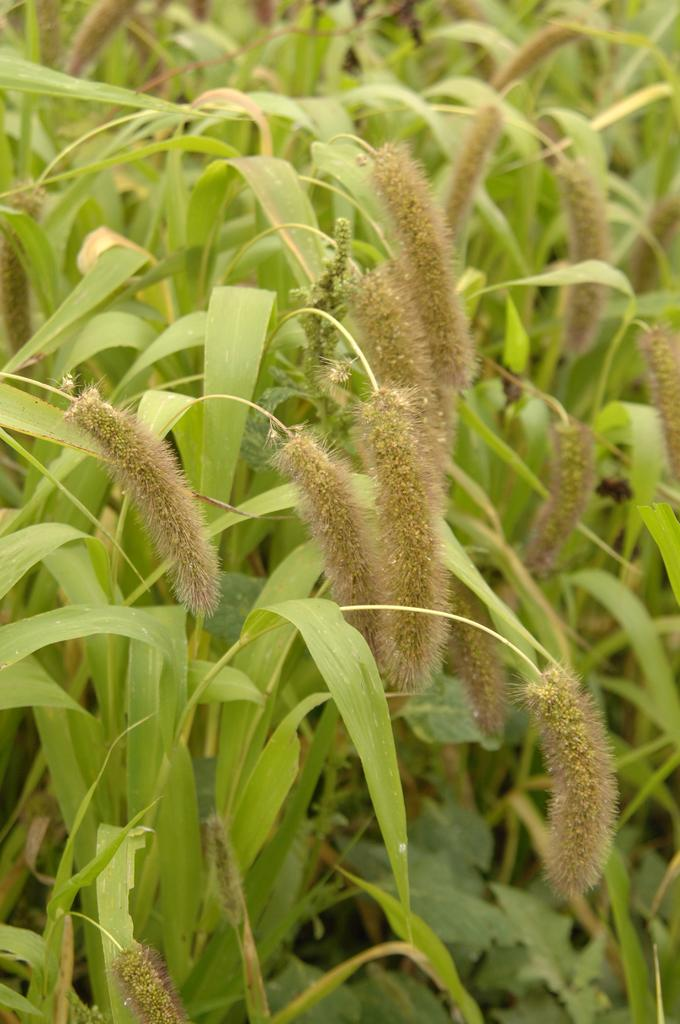What type of vegetation can be seen in the image? There are crops in the image. Can you describe the crops in more detail? Unfortunately, the image does not provide enough detail to describe the texture or specific type of crops. What type of mine can be seen in the image? There is no mine present in the image; it only features crops. 